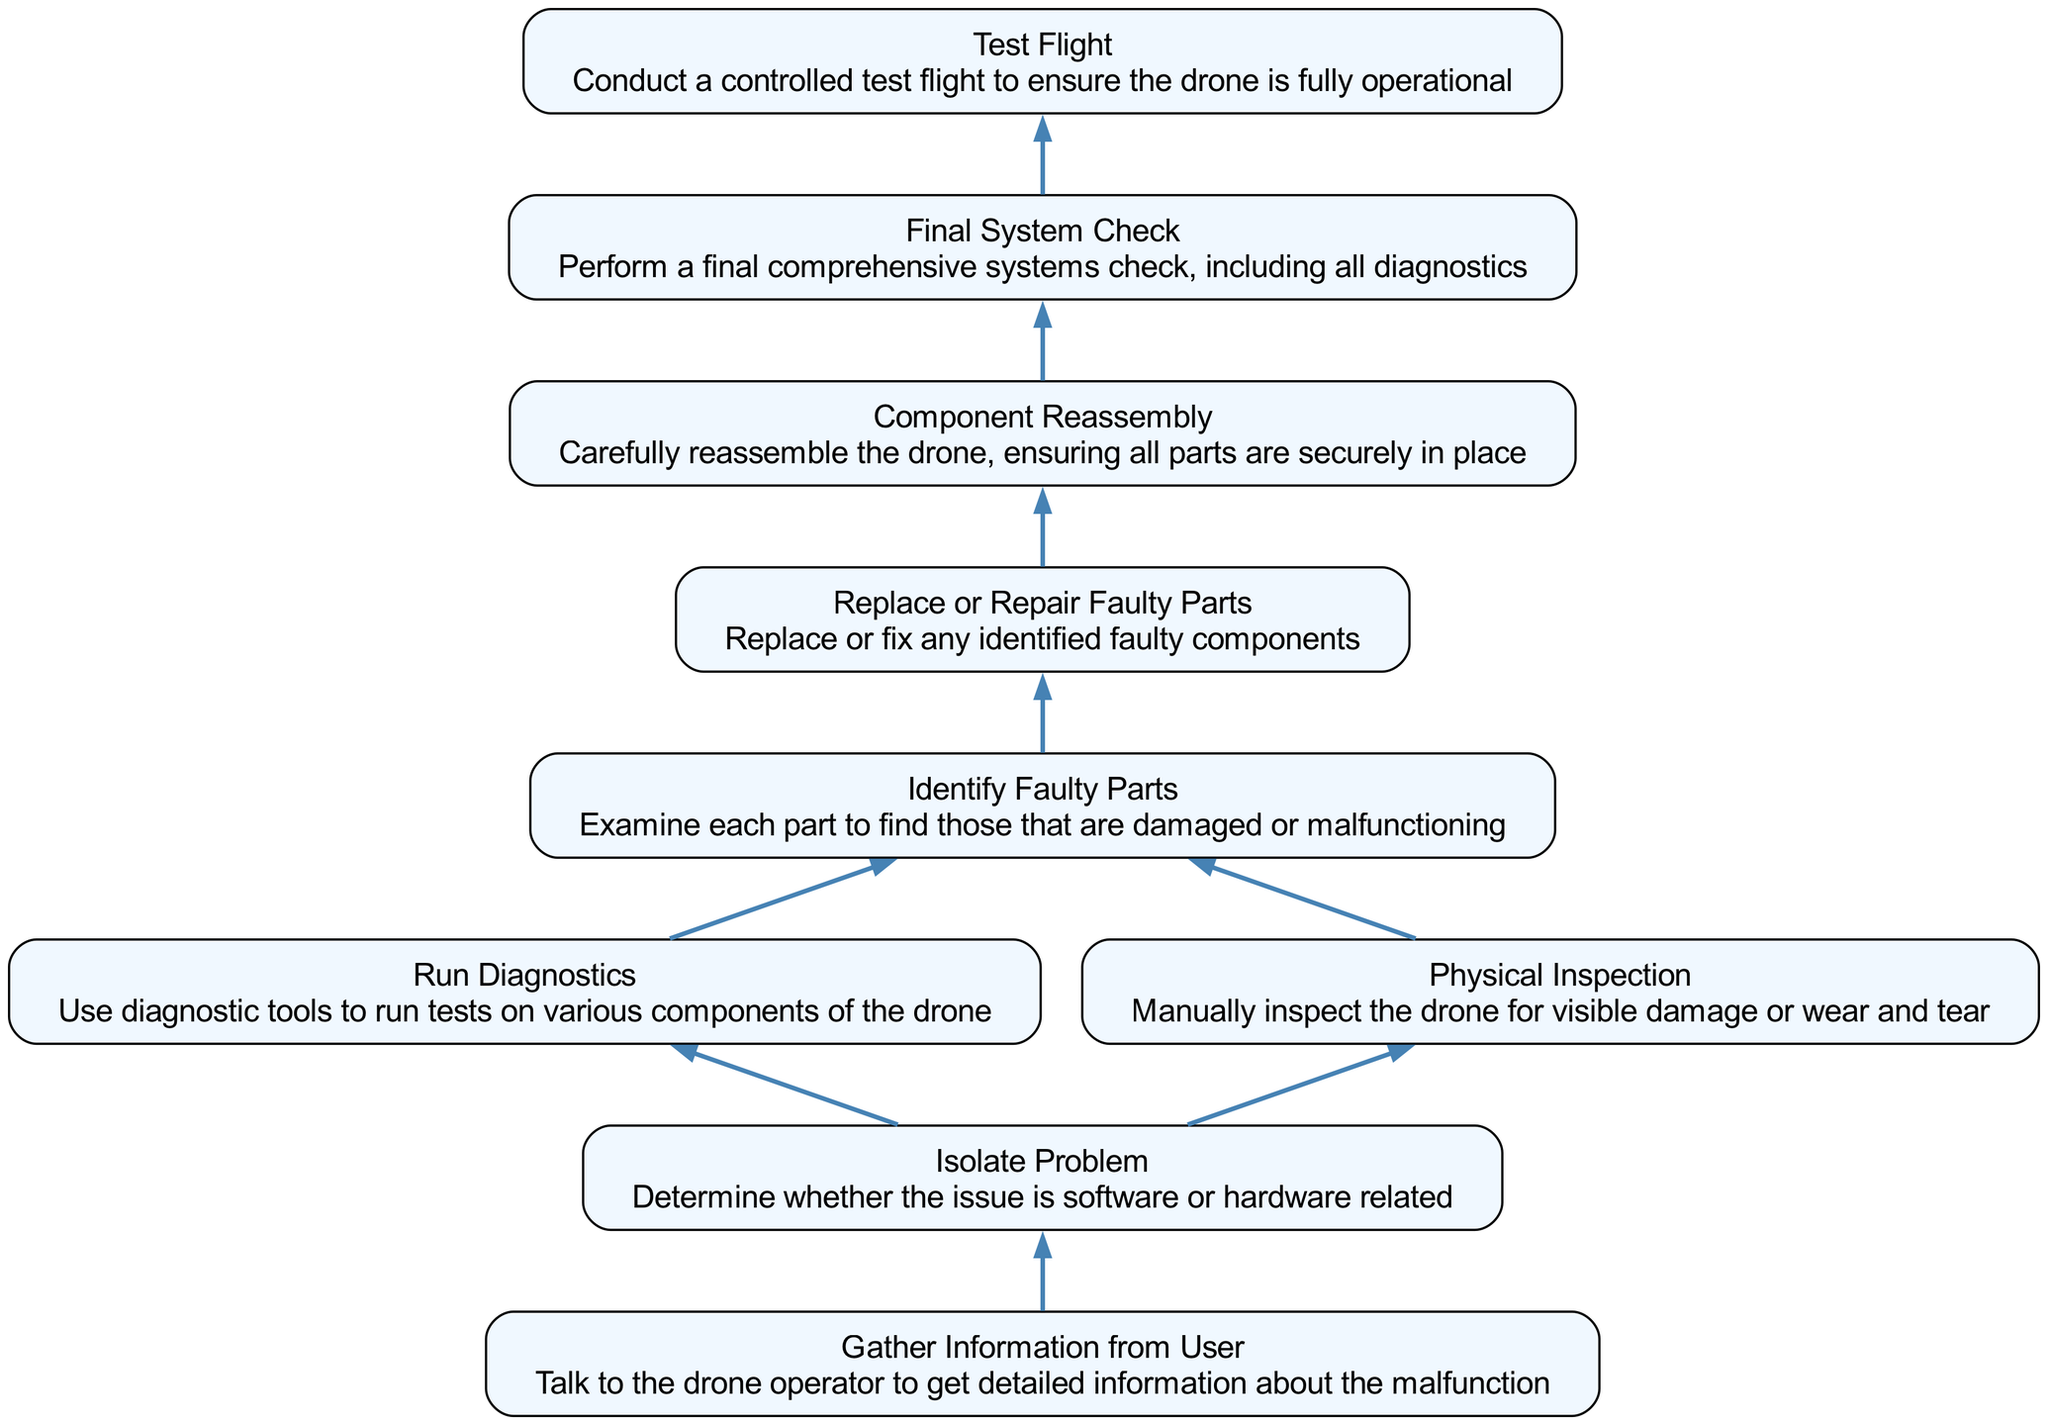What is the final step in the process? The final step is "Test Flight". It is the last action after completing all the preceding steps necessary for troubleshooting and repairing the drone.
Answer: Test Flight How many nodes are in the diagram? To determine the number of nodes, we count each unique step listed: Test Flight, Final System Check, Component Reassembly, Replace or Repair Faulty Parts, Identify Faulty Parts, Run Diagnostics, Physical Inspection, Isolate Problem, and Gather Information from User. This totals to nine nodes.
Answer: 9 What is the direct dependency for "Final System Check"? The direct dependency for "Final System Check" is "Component Reassembly", as the flow chart indicates that it follows after this step.
Answer: Component Reassembly Which step comes before "Replace or Repair Faulty Parts"? The step that comes before "Replace or Repair Faulty Parts" is "Identify Faulty Parts". This is necessary to perform repairs or replacements based on the diagnostic findings.
Answer: Identify Faulty Parts What is the sequence of actions from "Gather Information from User" to "Test Flight"? To reach "Test Flight", first, "Gather Information from User" is performed, which leads to "Isolate Problem", then this progresses to either "Run Diagnostics" or "Physical Inspection". After identifying faulty parts from either diagnostic route, the next step is "Replace or Repair Faulty Parts", followed by "Component Reassembly", then finally "Final System Check", culminating in "Test Flight".
Answer: Gather Information from User → Isolate Problem → Run Diagnostics/Physical Inspection → Identify Faulty Parts → Replace or Repair Faulty Parts → Component Reassembly → Final System Check → Test Flight How many steps require diagnostics? There are two steps explicitly labeled for diagnostics: "Run Diagnostics" and "Identify Faulty Parts" (which includes examining parts). Both contribute to the diagnostic process needed to troubleshoot the drone.
Answer: 2 